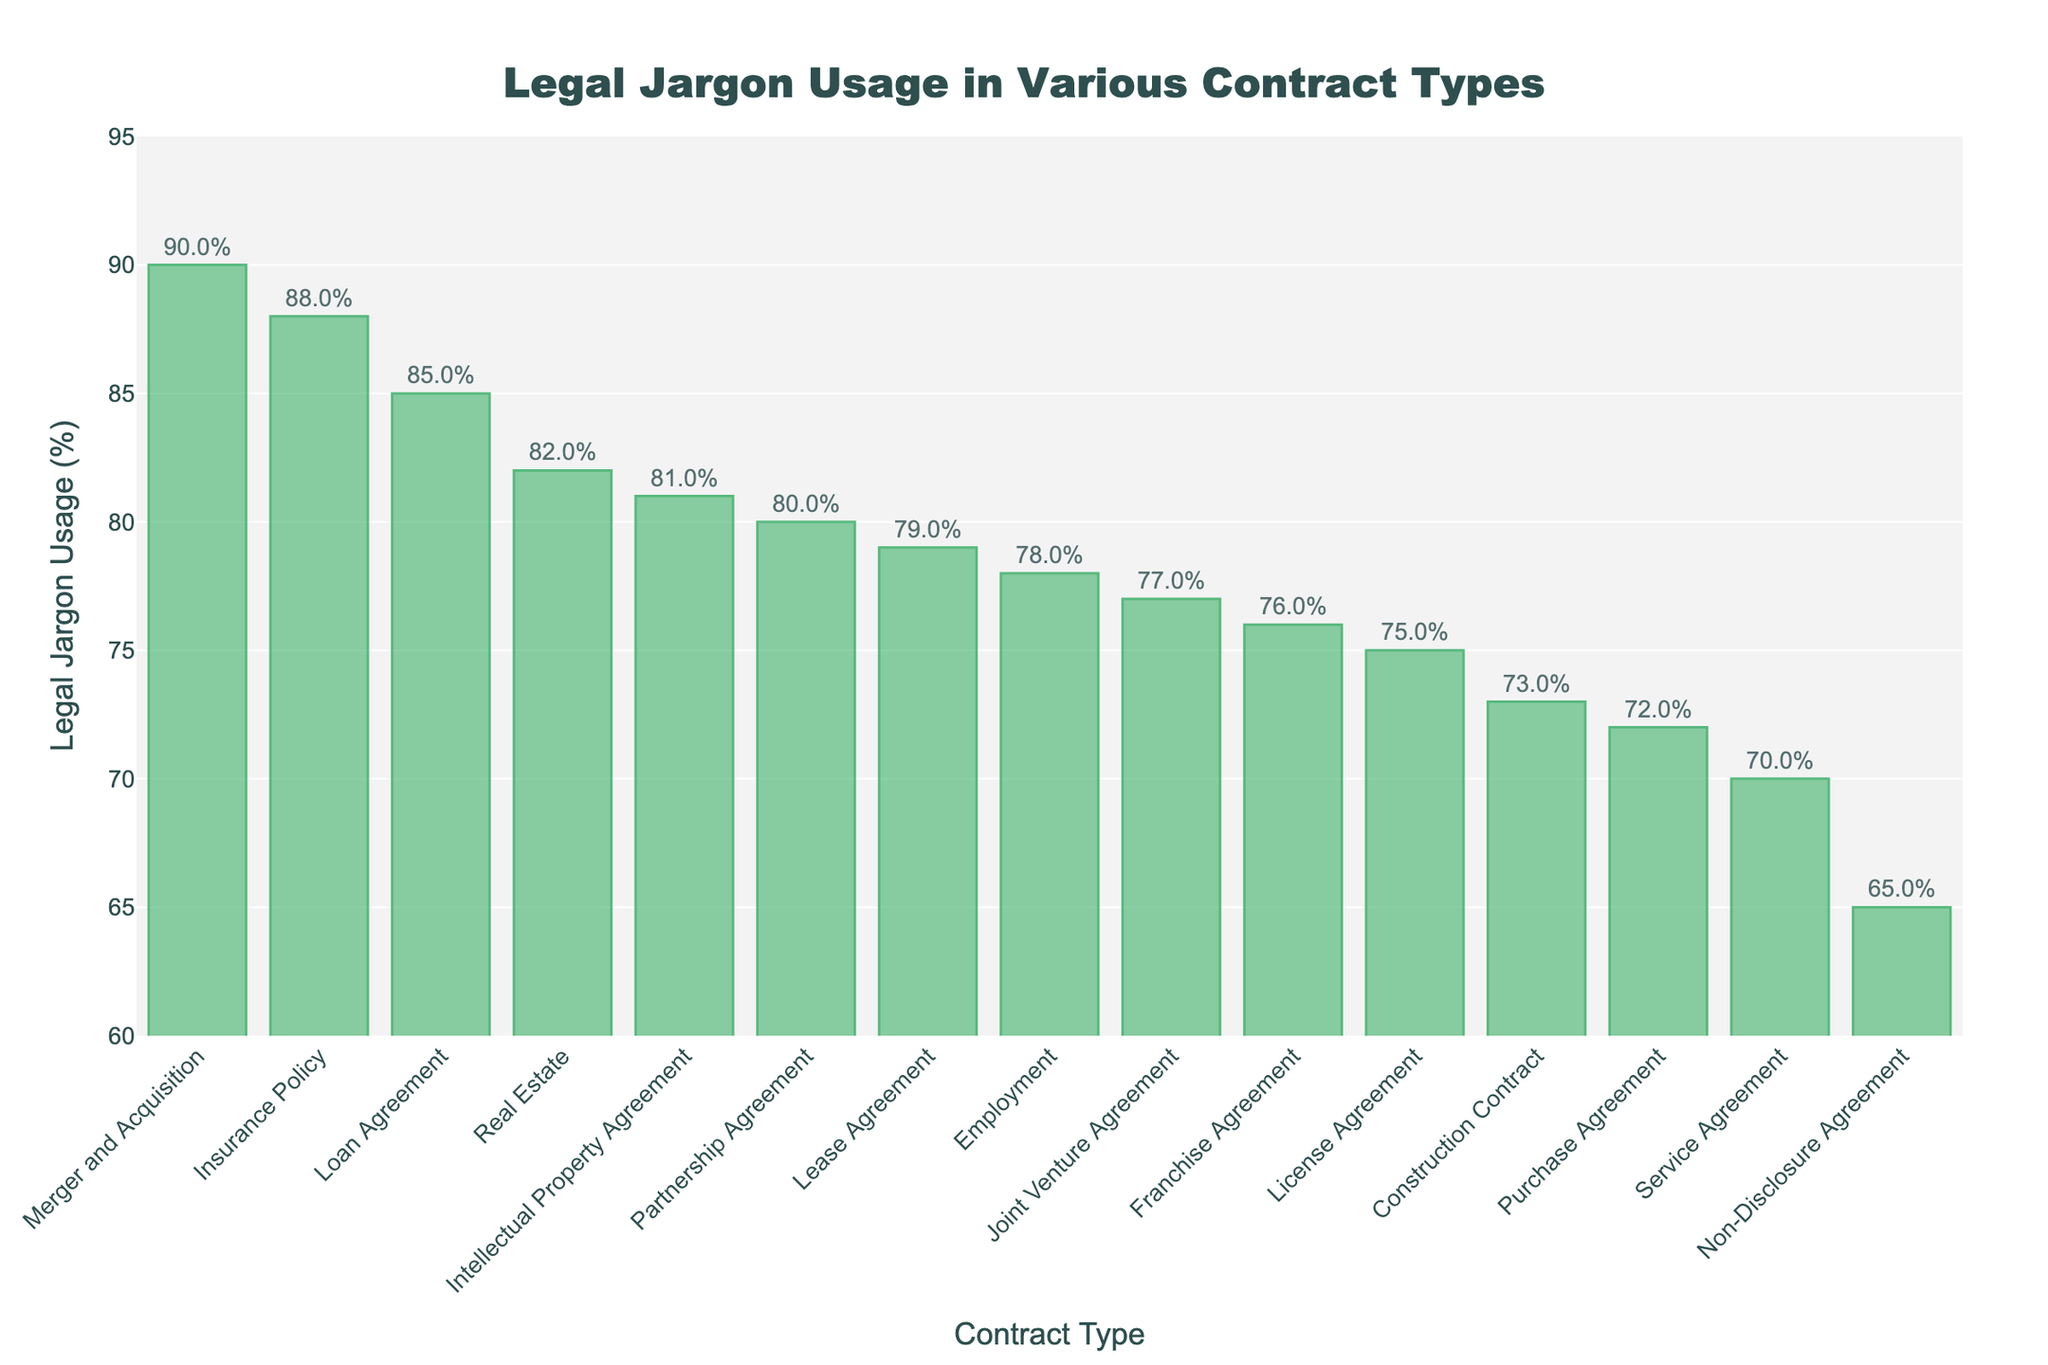Which contract type has the highest usage of legal jargon? The bar representing "Merger and Acquisition" is the tallest, indicating it has the highest percentage.
Answer: Merger and Acquisition Which contract type has the lowest usage of legal jargon? The bar representing "Non-Disclosure Agreement" is the shortest, indicating it has the lowest percentage.
Answer: Non-Disclosure Agreement What is the average usage of legal jargon across all contract types? Sum of all percentages divided by the number of contract types: (78 + 82 + 65 + 70 + 75 + 80 + 85 + 72 + 76 + 79 + 88 + 73 + 81 + 90 + 77) / 15 = 78.33%.
Answer: 78.33% How much higher is the legal jargon usage in "Insurance Policy" compared to "Non-Disclosure Agreement"? Subtract the percentage of "Non-Disclosure Agreement" (65%) from "Insurance Policy" (88%): 88 - 65 = 23%.
Answer: 23% Which contract types have legal jargon usage percentages above 80%? Identify bars with heights above the 80% mark: "Real Estate", "Partnership Agreement", "Loan Agreement", "Insurance Policy", "Intellectual Property Agreement", "Merger and Acquisition".
Answer: Real Estate, Partnership Agreement, Loan Agreement, Insurance Policy, Intellectual Property Agreement, Merger and Acquisition How does the legal jargon usage in "Lease Agreement" compare to "Employment"? The bar for "Lease Agreement" (79%) is slightly higher than "Employment" (78%).
Answer: Lease Agreement is higher If you combine the legal jargon usage of "Service Agreement" and "Loan Agreement", what is the total percentage? Sum the percentages: 70% for "Service Agreement" + 85% for "Loan Agreement" = 155%.
Answer: 155% Which contract type falls exactly below "Insurance Policy" in terms of legal jargon usage? The bar immediately below "Insurance Policy" (88%) is "Merger and Acquisition" (90%).
Answer: Merger and Acquisition What is the difference in the legal jargon usage between the highest (Merger and Acquisition) and the lowest (Non-Disclosure Agreement)? Subtract the percentage of "Non-Disclosure Agreement" (65%) from "Merger and Acquisition" (90%): 90 - 65 = 25%.
Answer: 25% How many contract types have a legal jargon usage between 70% and 80%? Count the bars that fall within this range: "Service Agreement" (70%), "Purchase Agreement" (72%), "Construction Contract" (73%), "Joint Venture Agreement" (77%), "Franchise Agreement" (76%), "Employment" (78%), and "Lease Agreement" (79%). There are 7 contract types.
Answer: 7 